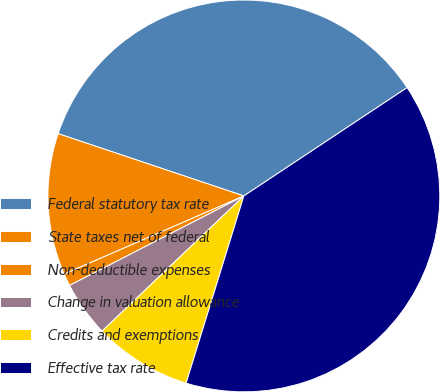Convert chart to OTSL. <chart><loc_0><loc_0><loc_500><loc_500><pie_chart><fcel>Federal statutory tax rate<fcel>State taxes net of federal<fcel>Non-deductible expenses<fcel>Change in valuation allowance<fcel>Credits and exemptions<fcel>Effective tax rate<nl><fcel>35.53%<fcel>11.68%<fcel>1.02%<fcel>4.57%<fcel>8.12%<fcel>39.09%<nl></chart> 